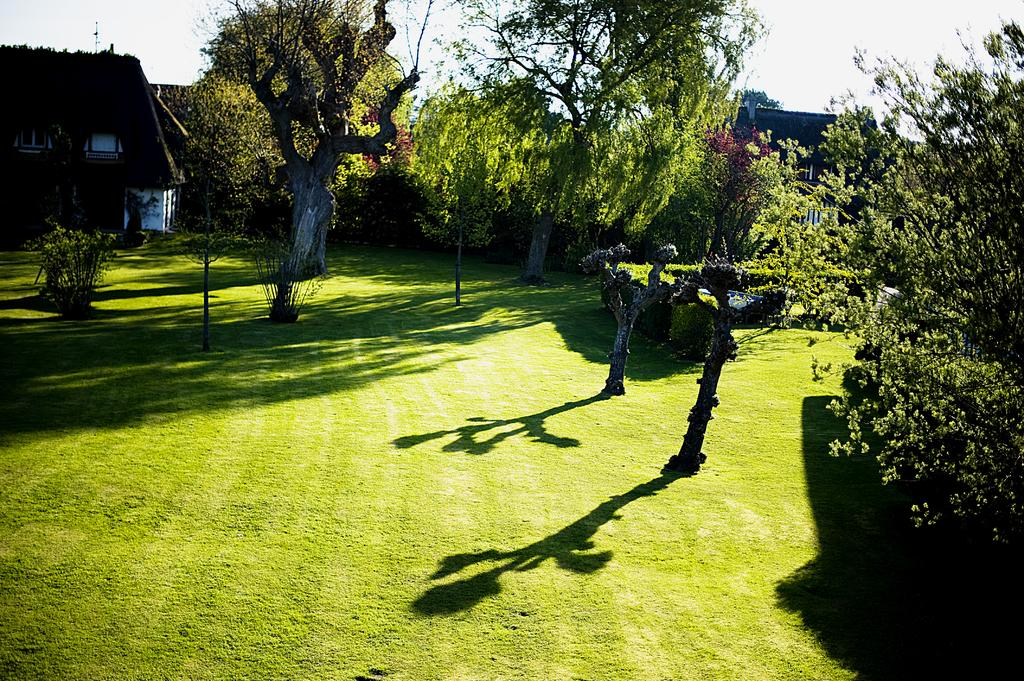What type of vegetation can be seen in the image? There are trees with branches and leaves in the image, as well as small bushes. What is the condition of the trees in the image? The trees have branches and leaves, and their shadows are visible on the grass. What type of structure is present in the image? There is a house with windows in the image. What type of milk is being poured from the vessel in the image? There is no vessel or milk present in the image; it features trees, bushes, and a house. 